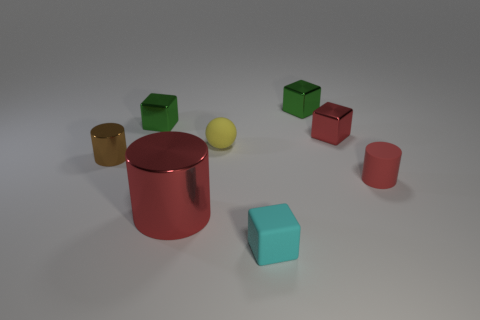There is a brown cylinder; are there any small cylinders on the right side of it?
Keep it short and to the point. Yes. Do the small cylinder that is to the left of the tiny yellow sphere and the small matte block that is in front of the brown metallic object have the same color?
Provide a succinct answer. No. Are there any other large red shiny objects that have the same shape as the big red metallic thing?
Your answer should be compact. No. What number of other objects are there of the same color as the small matte cube?
Give a very brief answer. 0. There is a small cylinder left of the small metallic block that is in front of the tiny metal block left of the small rubber cube; what is its color?
Make the answer very short. Brown. Are there the same number of yellow matte balls behind the tiny red cube and matte cubes?
Ensure brevity in your answer.  No. There is a cube in front of the rubber cylinder; is its size the same as the red matte cylinder?
Offer a terse response. Yes. How many large blocks are there?
Your answer should be compact. 0. How many objects are both behind the big red shiny thing and right of the big metal cylinder?
Provide a succinct answer. 4. Are there any other tiny brown cylinders that have the same material as the brown cylinder?
Offer a terse response. No. 